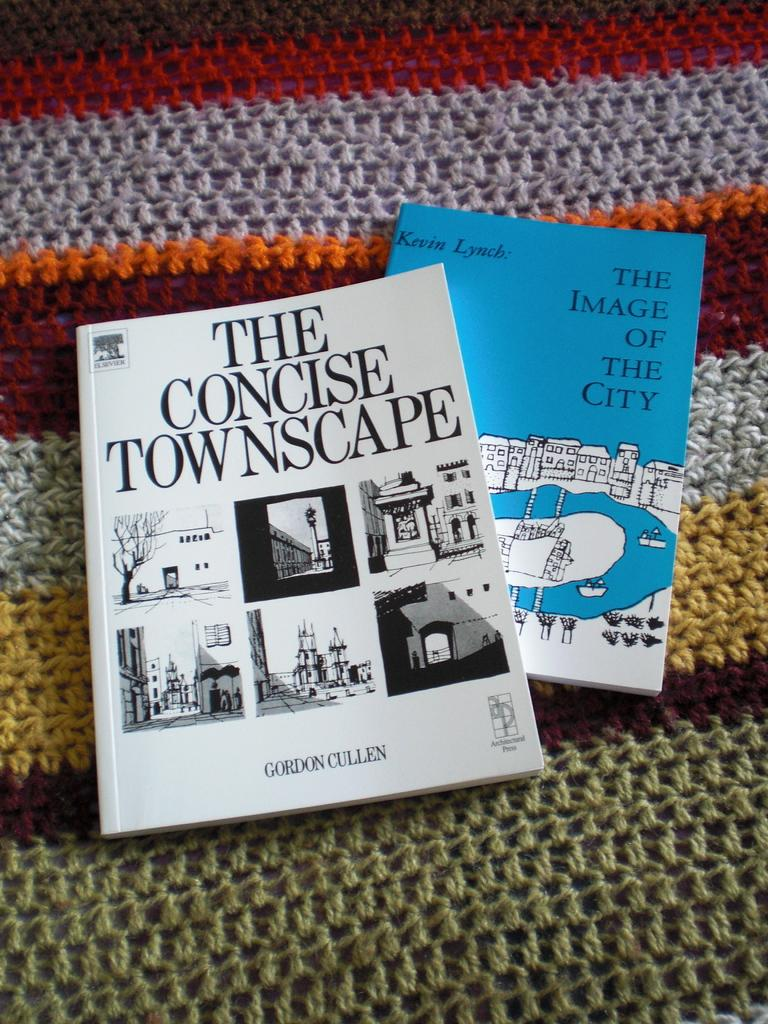<image>
Present a compact description of the photo's key features. Two books on the ground with one that says The Concise Townscape. 